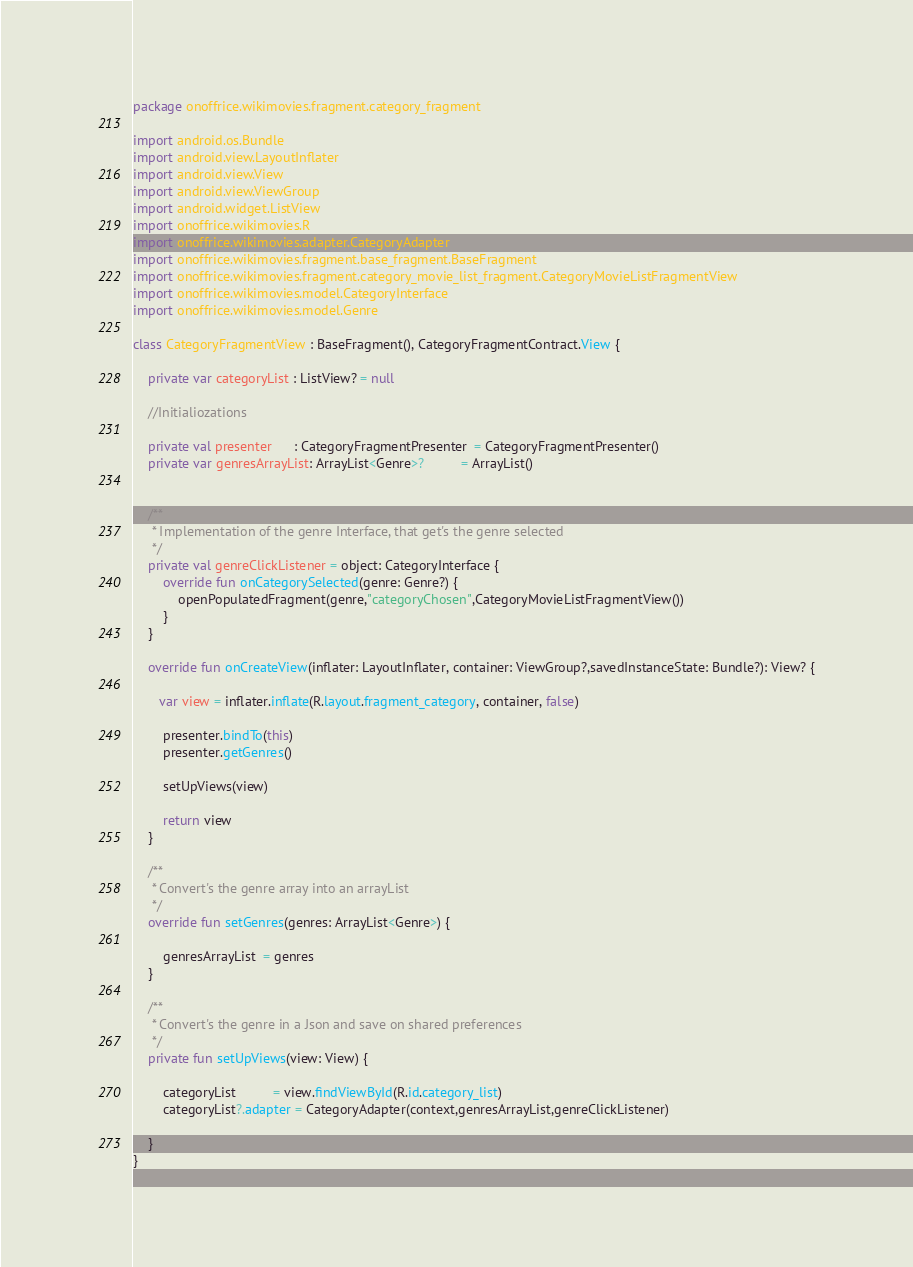<code> <loc_0><loc_0><loc_500><loc_500><_Kotlin_>package onoffrice.wikimovies.fragment.category_fragment

import android.os.Bundle
import android.view.LayoutInflater
import android.view.View
import android.view.ViewGroup
import android.widget.ListView
import onoffrice.wikimovies.R
import onoffrice.wikimovies.adapter.CategoryAdapter
import onoffrice.wikimovies.fragment.base_fragment.BaseFragment
import onoffrice.wikimovies.fragment.category_movie_list_fragment.CategoryMovieListFragmentView
import onoffrice.wikimovies.model.CategoryInterface
import onoffrice.wikimovies.model.Genre

class CategoryFragmentView : BaseFragment(), CategoryFragmentContract.View {

    private var categoryList : ListView? = null

    //Initialiozations

    private val presenter      : CategoryFragmentPresenter  = CategoryFragmentPresenter()
    private var genresArrayList: ArrayList<Genre>?          = ArrayList()


    /**
     * Implementation of the genre Interface, that get's the genre selected
     */
    private val genreClickListener = object: CategoryInterface {
        override fun onCategorySelected(genre: Genre?) {
            openPopulatedFragment(genre,"categoryChosen",CategoryMovieListFragmentView())
        }
    }

    override fun onCreateView(inflater: LayoutInflater, container: ViewGroup?,savedInstanceState: Bundle?): View? {

       var view = inflater.inflate(R.layout.fragment_category, container, false)

        presenter.bindTo(this)
        presenter.getGenres()

        setUpViews(view)

        return view
    }

    /**
     * Convert's the genre array into an arrayList
     */
    override fun setGenres(genres: ArrayList<Genre>) {

        genresArrayList  = genres
    }

    /**
     * Convert's the genre in a Json and save on shared preferences
     */
    private fun setUpViews(view: View) {

        categoryList          = view.findViewById(R.id.category_list)
        categoryList?.adapter = CategoryAdapter(context,genresArrayList,genreClickListener)

    }
}
</code> 